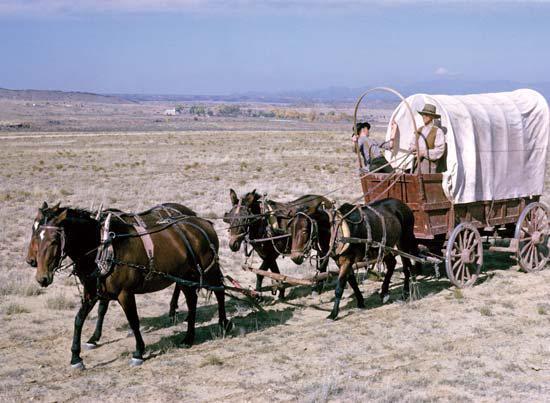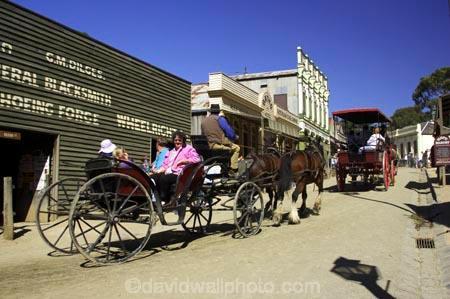The first image is the image on the left, the second image is the image on the right. For the images shown, is this caption "An image shows a four-wheeled horse-drawn wagon with some type of white canopy." true? Answer yes or no. Yes. The first image is the image on the left, the second image is the image on the right. Evaluate the accuracy of this statement regarding the images: "A white horse is pulling one of the carts.". Is it true? Answer yes or no. No. 